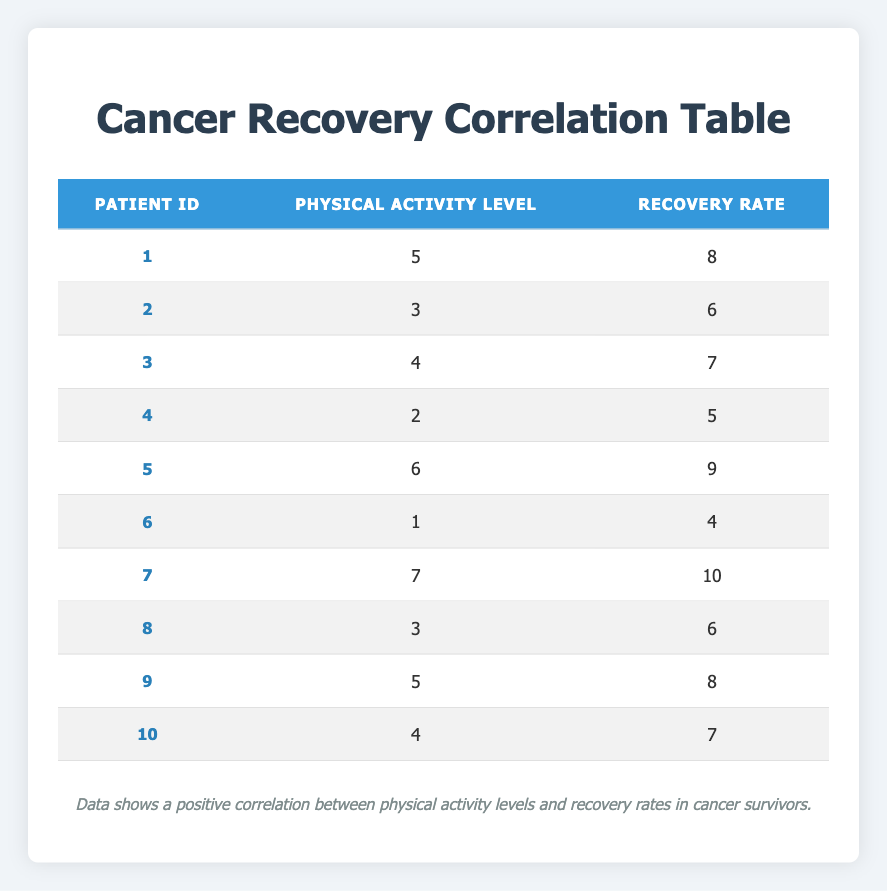What is the physical activity level of Patient ID 7? By looking at the row for Patient ID 7 in the table, the Physical Activity Level is directly presented as 7.
Answer: 7 What is the recovery rate of the patient with the lowest physical activity level? The lowest physical activity level in the table is 1, which corresponds to Patient ID 6. The Recovery Rate for this patient is 4.
Answer: 4 How many patients have a physical activity level of 4? There are two patients with a Physical Activity Level of 4: Patient ID 3 and Patient ID 10. Therefore, the count is 2.
Answer: 2 What is the average recovery rate of patients with a physical activity level of 5? The patients with a physical activity level of 5 are Patient ID 1 and Patient ID 9. Their Recovery Rates are 8 and 8 respectively. The average is calculated as (8 + 8) / 2 = 8.
Answer: 8 Is the Recovery Rate for Patient ID 5 greater than for Patient ID 2? Looking at the table, Patient ID 5 has a Recovery Rate of 9 and Patient ID 2 has a Recovery Rate of 6. Since 9 is greater than 6, the statement is true.
Answer: Yes What is the combined recovery rate of patients with physical activity levels 3? The patients with a Physical Activity Level of 3 are Patient ID 2, Patient ID 8. Their Recovery Rates are 6 for both. The combined recovery rate is calculated as 6 + 6 = 12.
Answer: 12 Is there a clear correlation between physical activity levels and recovery rates based on the available data? Observing the table, as the physical activity level increases, the recovery rate generally increases as well, indicating a positive correlation.
Answer: Yes What percentage of patients have a recovery rate above 7? The patients with Recovery Rates above 7 are Patient ID 5, Patient ID 7, and Patient ID 9. That's 3 out of 10 patients giving a percentage of (3/10) * 100 = 30%.
Answer: 30% What is the difference in recovery rates between the patient with the highest physical activity level and the patient with the lowest? The patient with the highest physical activity level is Patient ID 7 with a Recovery Rate of 10, and the patient with the lowest physical activity level is Patient ID 6 with a Recovery Rate of 4. The difference is calculated as 10 - 4 = 6.
Answer: 6 